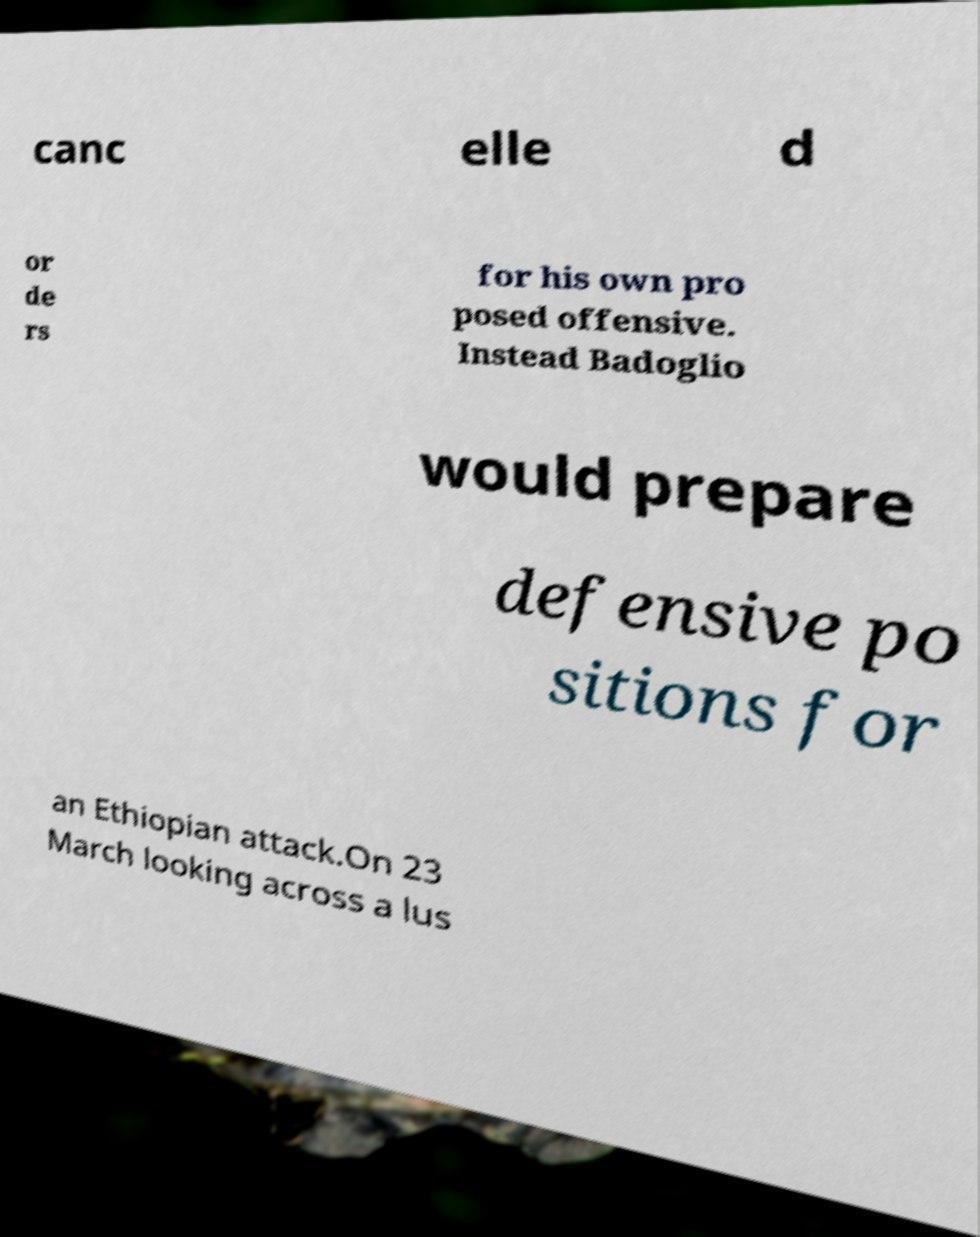I need the written content from this picture converted into text. Can you do that? canc elle d or de rs for his own pro posed offensive. Instead Badoglio would prepare defensive po sitions for an Ethiopian attack.On 23 March looking across a lus 